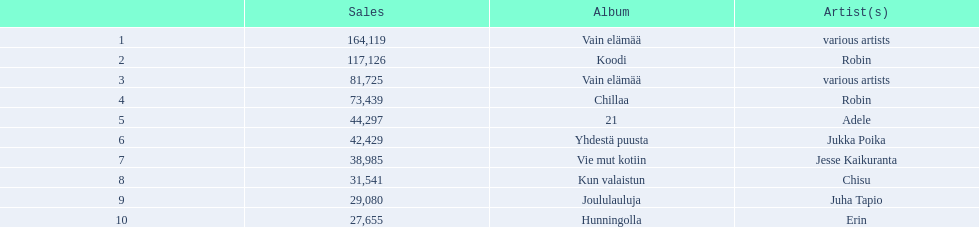Tell me an album that had the same artist as chillaa. Koodi. 